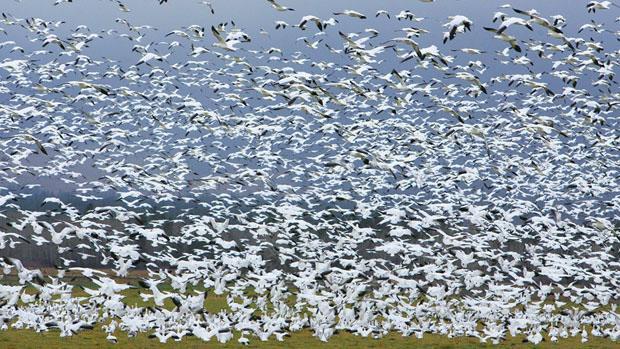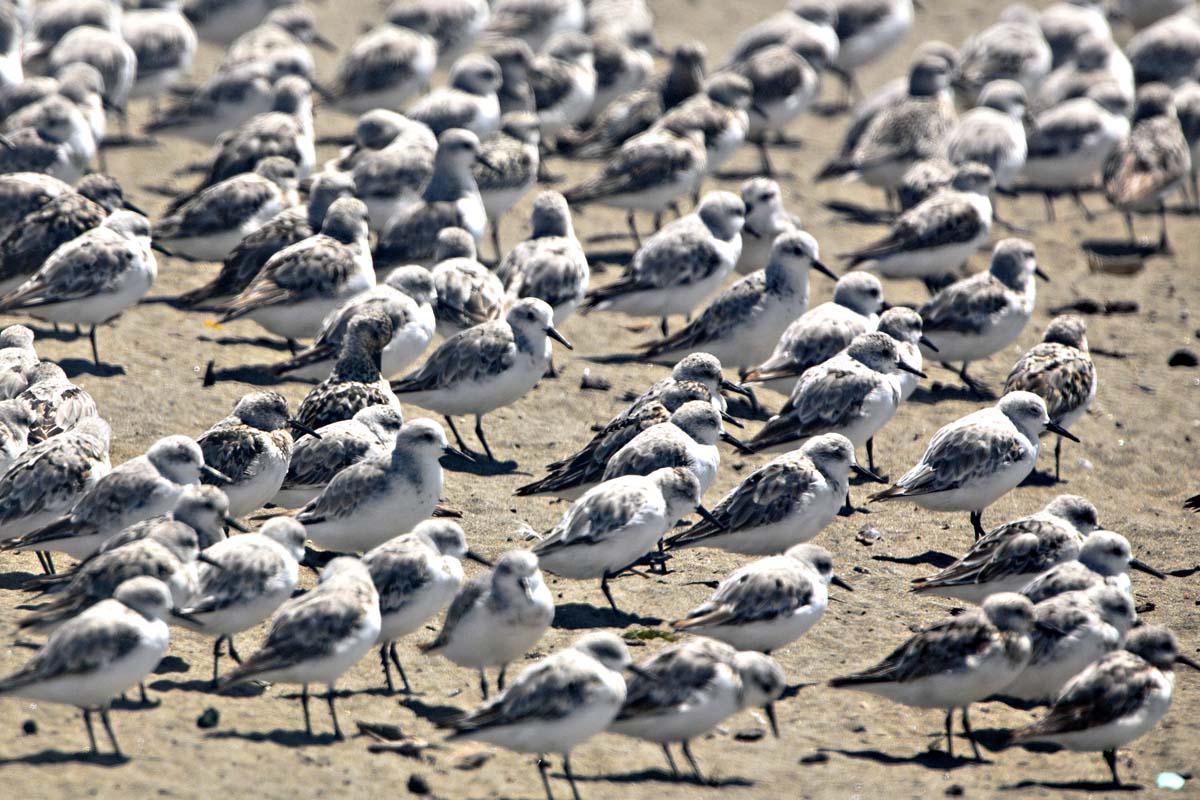The first image is the image on the left, the second image is the image on the right. Given the left and right images, does the statement "A body of water is visible below a sky full of birds in at least one image." hold true? Answer yes or no. No. 